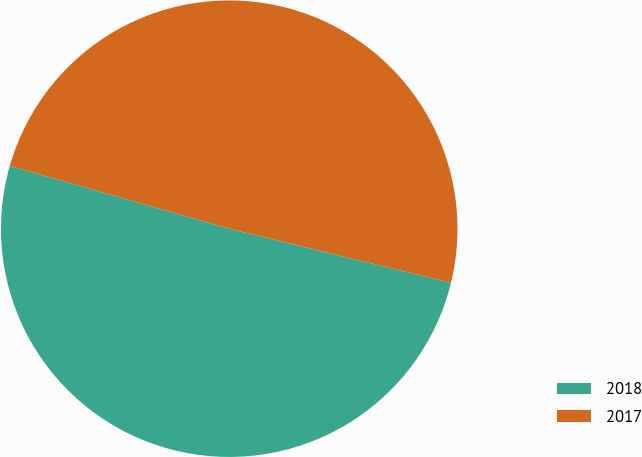Convert chart. <chart><loc_0><loc_0><loc_500><loc_500><pie_chart><fcel>2018<fcel>2017<nl><fcel>50.63%<fcel>49.37%<nl></chart> 